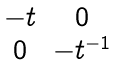Convert formula to latex. <formula><loc_0><loc_0><loc_500><loc_500>\begin{matrix} - t & 0 \\ 0 & - t ^ { - 1 } \end{matrix}</formula> 